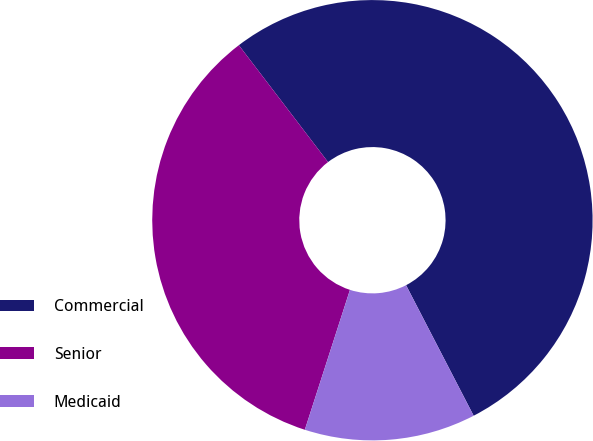Convert chart to OTSL. <chart><loc_0><loc_0><loc_500><loc_500><pie_chart><fcel>Commercial<fcel>Senior<fcel>Medicaid<nl><fcel>52.77%<fcel>34.66%<fcel>12.57%<nl></chart> 